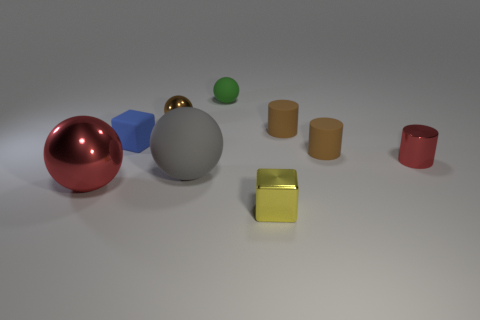What is the shape of the small red thing that is made of the same material as the tiny yellow thing?
Keep it short and to the point. Cylinder. There is a green ball that is on the right side of the red metal ball; how big is it?
Keep it short and to the point. Small. Are there the same number of small brown rubber things on the left side of the small green rubber object and big things that are left of the rubber cube?
Your answer should be compact. No. The large sphere that is to the right of the red metal thing that is left of the small matte ball that is behind the gray matte object is what color?
Offer a terse response. Gray. How many shiny things are behind the yellow cube and on the right side of the small rubber sphere?
Offer a very short reply. 1. Does the tiny rubber cylinder behind the blue block have the same color as the tiny shiny thing right of the tiny yellow metallic cube?
Provide a short and direct response. No. Is there any other thing that has the same material as the yellow block?
Provide a short and direct response. Yes. What is the size of the blue thing that is the same shape as the yellow object?
Provide a succinct answer. Small. Are there any blue rubber blocks behind the small blue cube?
Give a very brief answer. No. Are there an equal number of metallic things that are behind the red shiny ball and cylinders?
Offer a terse response. No. 